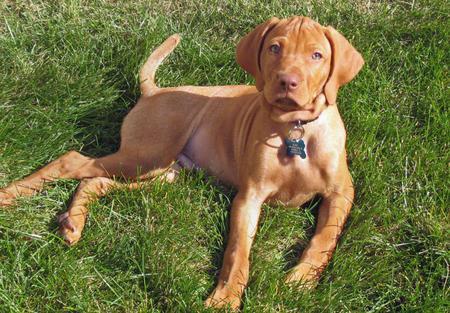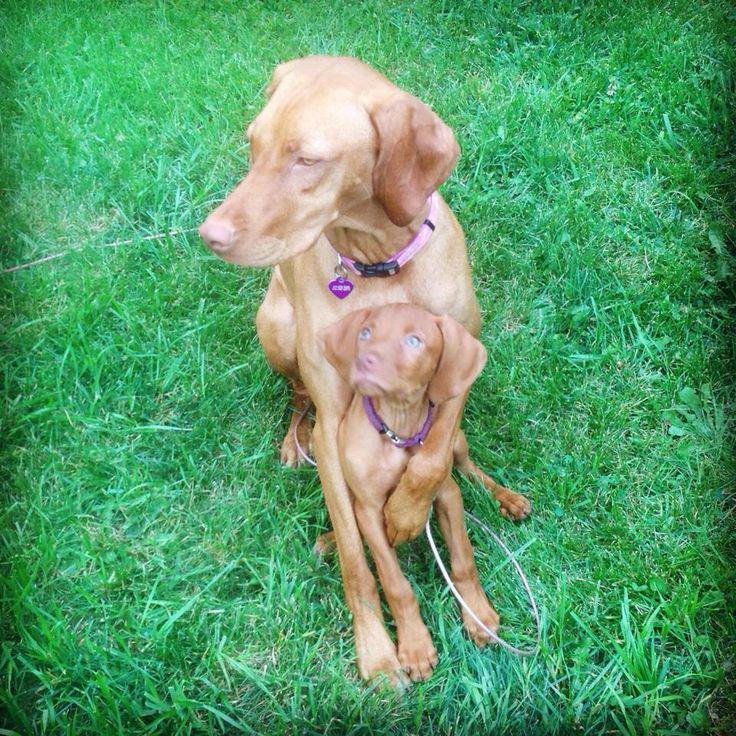The first image is the image on the left, the second image is the image on the right. Evaluate the accuracy of this statement regarding the images: "The dog in the image on the left is standing in the grass.". Is it true? Answer yes or no. No. The first image is the image on the left, the second image is the image on the right. Considering the images on both sides, is "Each image contains exactly one red-orange dog, one image shows a puppy headed across the grass with a front paw raised, and the other shows a dog wearing a bluish collar." valid? Answer yes or no. No. 